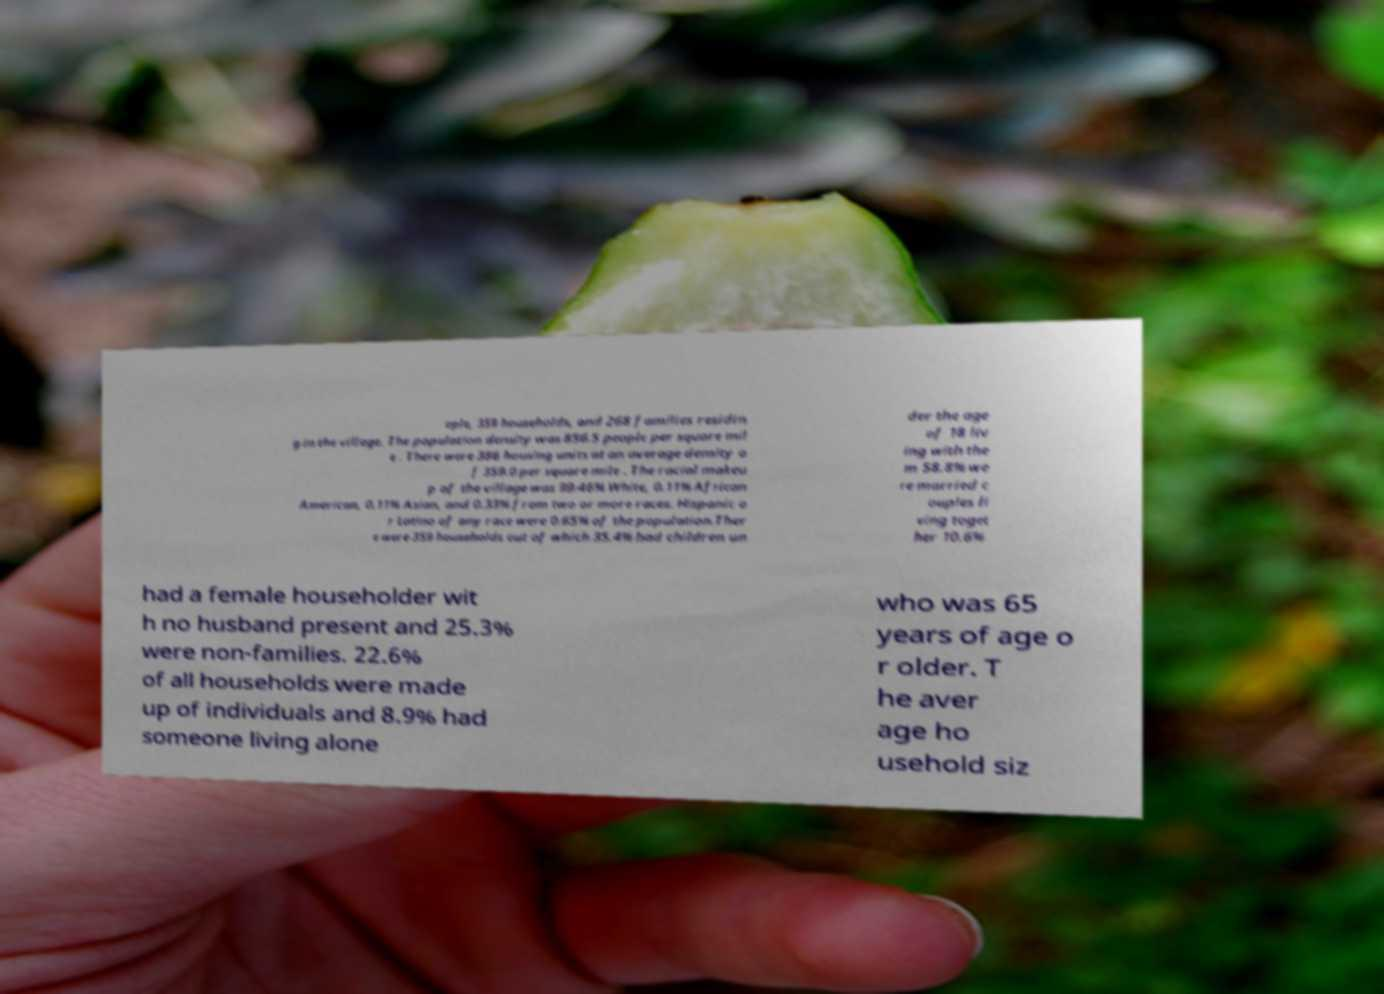Can you accurately transcribe the text from the provided image for me? ople, 359 households, and 268 families residin g in the village. The population density was 856.5 people per square mil e . There were 386 housing units at an average density o f 359.0 per square mile . The racial makeu p of the village was 99.46% White, 0.11% African American, 0.11% Asian, and 0.33% from two or more races. Hispanic o r Latino of any race were 0.65% of the population.Ther e were 359 households out of which 35.4% had children un der the age of 18 liv ing with the m 58.8% we re married c ouples li ving toget her 10.6% had a female householder wit h no husband present and 25.3% were non-families. 22.6% of all households were made up of individuals and 8.9% had someone living alone who was 65 years of age o r older. T he aver age ho usehold siz 